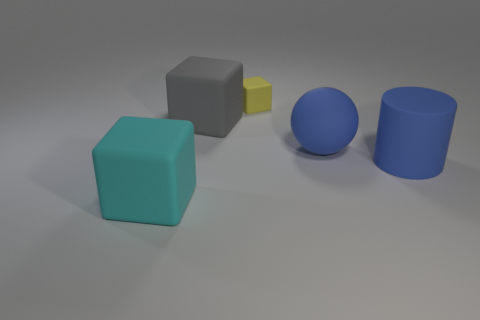Subtract 1 cubes. How many cubes are left? 2 Subtract all big cubes. How many cubes are left? 1 Add 3 blue rubber spheres. How many objects exist? 8 Subtract all blue cubes. Subtract all brown spheres. How many cubes are left? 3 Subtract all blocks. How many objects are left? 2 Subtract all things. Subtract all small cyan cubes. How many objects are left? 0 Add 1 big blue spheres. How many big blue spheres are left? 2 Add 2 small cyan objects. How many small cyan objects exist? 2 Subtract 1 cyan blocks. How many objects are left? 4 